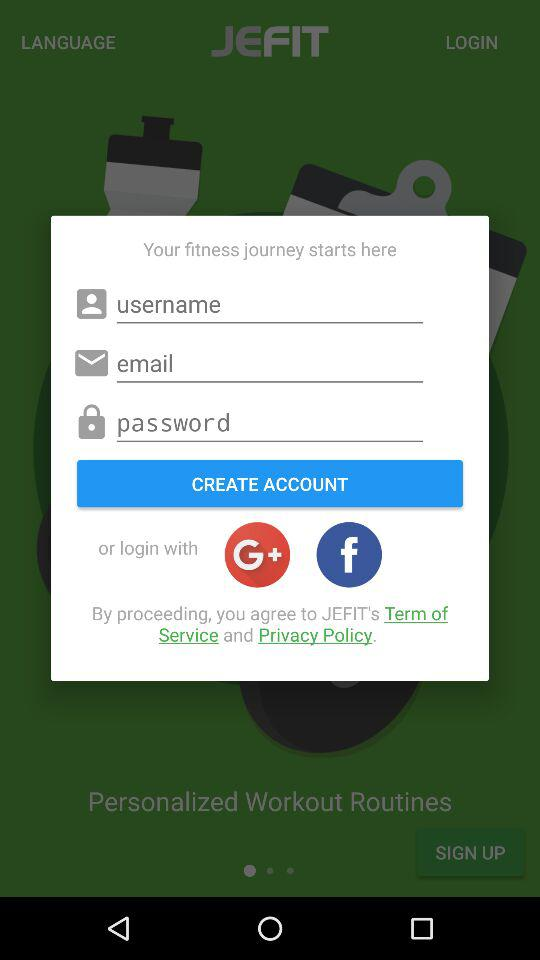What is the name of the application? The name of the application is "JEFIT". 